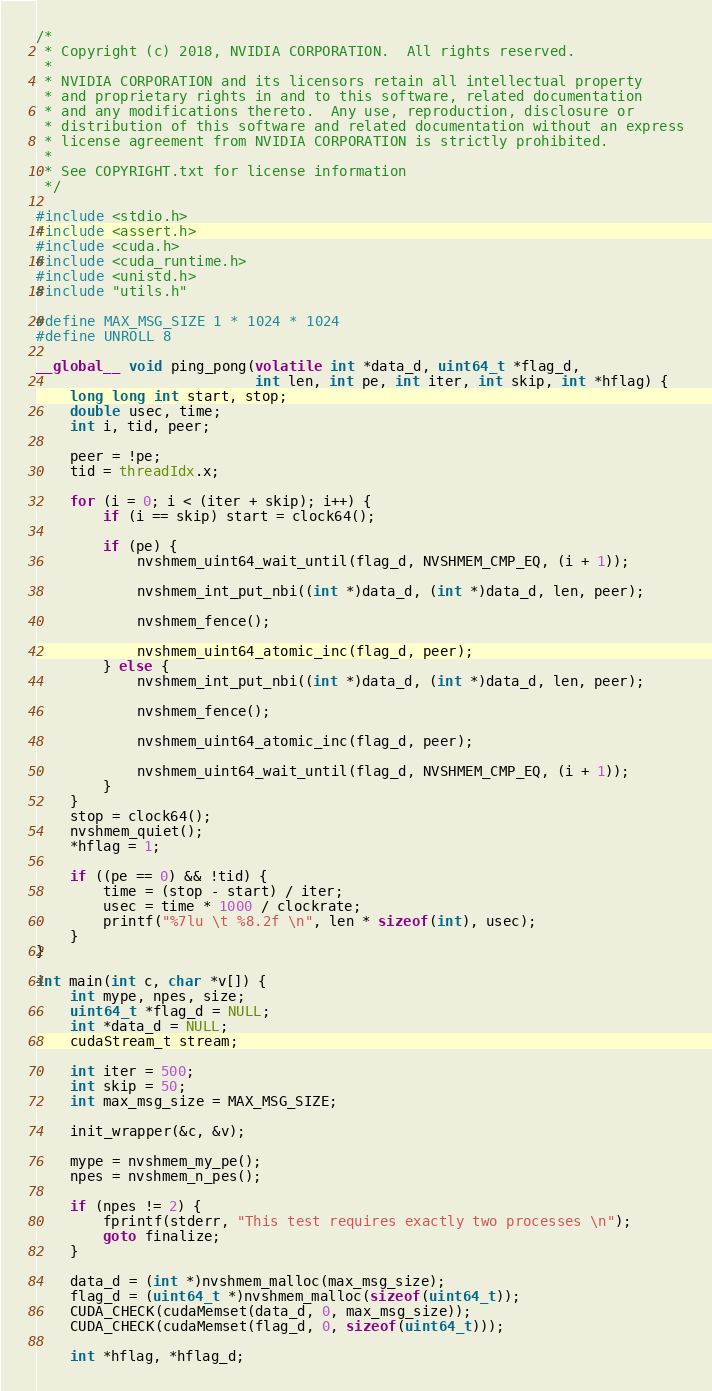<code> <loc_0><loc_0><loc_500><loc_500><_Cuda_>/*
 * Copyright (c) 2018, NVIDIA CORPORATION.  All rights reserved.
 *
 * NVIDIA CORPORATION and its licensors retain all intellectual property
 * and proprietary rights in and to this software, related documentation
 * and any modifications thereto.  Any use, reproduction, disclosure or
 * distribution of this software and related documentation without an express
 * license agreement from NVIDIA CORPORATION is strictly prohibited.
 *
 * See COPYRIGHT.txt for license information
 */

#include <stdio.h>
#include <assert.h>
#include <cuda.h>
#include <cuda_runtime.h>
#include <unistd.h>
#include "utils.h"

#define MAX_MSG_SIZE 1 * 1024 * 1024
#define UNROLL 8

__global__ void ping_pong(volatile int *data_d, uint64_t *flag_d,
                          int len, int pe, int iter, int skip, int *hflag) {
    long long int start, stop;
    double usec, time;
    int i, tid, peer;

    peer = !pe;
    tid = threadIdx.x;

    for (i = 0; i < (iter + skip); i++) {
        if (i == skip) start = clock64();

        if (pe) {
            nvshmem_uint64_wait_until(flag_d, NVSHMEM_CMP_EQ, (i + 1));

            nvshmem_int_put_nbi((int *)data_d, (int *)data_d, len, peer);

            nvshmem_fence();

            nvshmem_uint64_atomic_inc(flag_d, peer);
        } else {
            nvshmem_int_put_nbi((int *)data_d, (int *)data_d, len, peer);

            nvshmem_fence();

            nvshmem_uint64_atomic_inc(flag_d, peer);

            nvshmem_uint64_wait_until(flag_d, NVSHMEM_CMP_EQ, (i + 1));
        }
    }
    stop = clock64();
    nvshmem_quiet();
    *hflag = 1;

    if ((pe == 0) && !tid) {
        time = (stop - start) / iter;
        usec = time * 1000 / clockrate;
        printf("%7lu \t %8.2f \n", len * sizeof(int), usec);
    }
}

int main(int c, char *v[]) {
    int mype, npes, size;
    uint64_t *flag_d = NULL;
    int *data_d = NULL;
    cudaStream_t stream;

    int iter = 500;
    int skip = 50;
    int max_msg_size = MAX_MSG_SIZE;

    init_wrapper(&c, &v);

    mype = nvshmem_my_pe();
    npes = nvshmem_n_pes();

    if (npes != 2) {
        fprintf(stderr, "This test requires exactly two processes \n");
        goto finalize;
    }

    data_d = (int *)nvshmem_malloc(max_msg_size);
    flag_d = (uint64_t *)nvshmem_malloc(sizeof(uint64_t));
    CUDA_CHECK(cudaMemset(data_d, 0, max_msg_size));
    CUDA_CHECK(cudaMemset(flag_d, 0, sizeof(uint64_t)));

    int *hflag, *hflag_d;</code> 